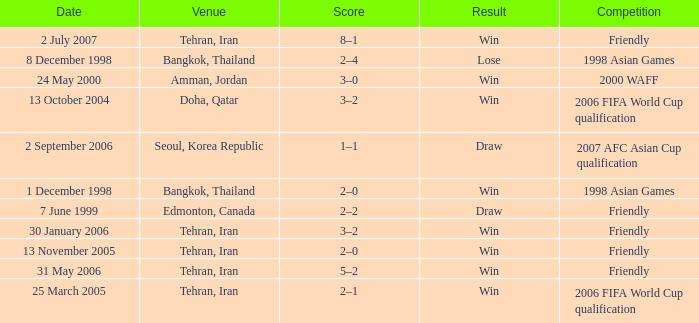What was the competition on 13 November 2005? Friendly. 